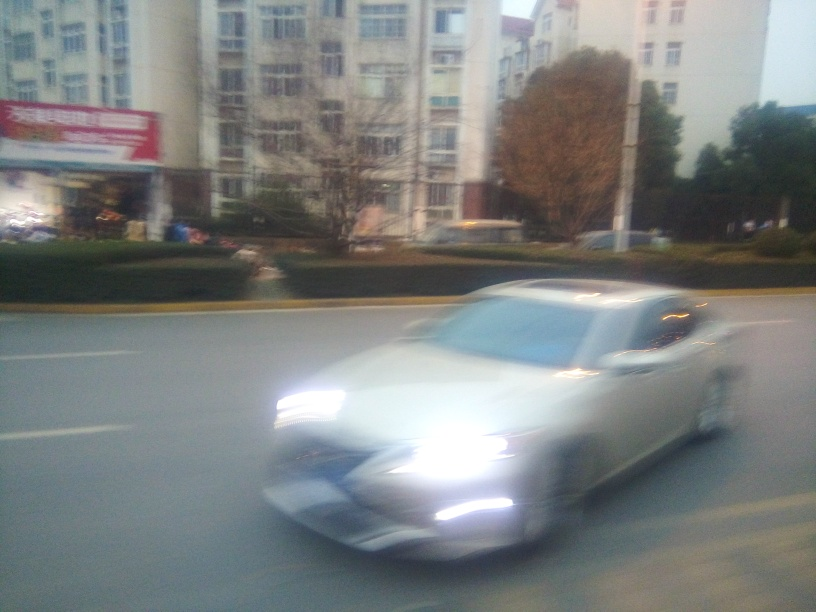What is the problem with the focus?
A. Blurry image overall.
B. Clear and sharp focus.
C. Soft focus.
Answer with the option's letter from the given choices directly.
 A. 